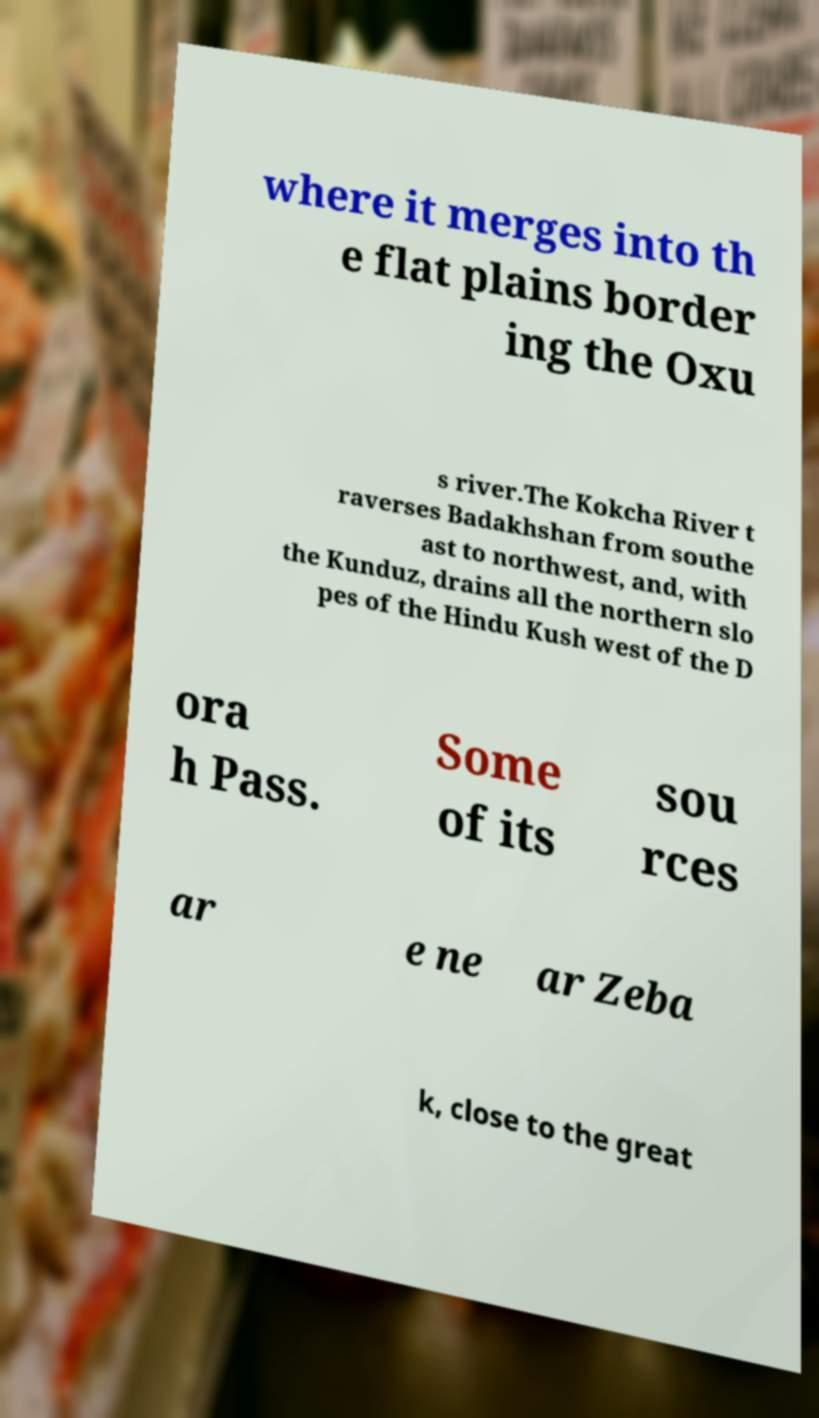Can you read and provide the text displayed in the image?This photo seems to have some interesting text. Can you extract and type it out for me? where it merges into th e flat plains border ing the Oxu s river.The Kokcha River t raverses Badakhshan from southe ast to northwest, and, with the Kunduz, drains all the northern slo pes of the Hindu Kush west of the D ora h Pass. Some of its sou rces ar e ne ar Zeba k, close to the great 